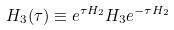<formula> <loc_0><loc_0><loc_500><loc_500>H _ { 3 } ( \tau ) \equiv e ^ { \tau H _ { 2 } } H _ { 3 } e ^ { - \tau H _ { 2 } }</formula> 